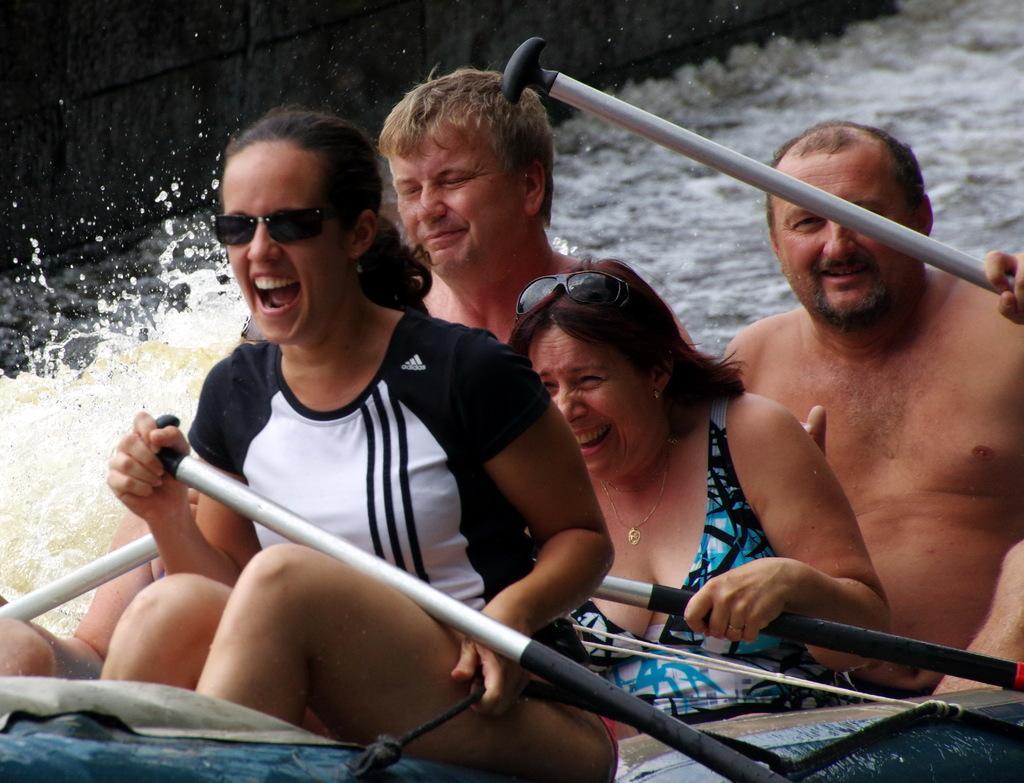Could you give a brief overview of what you see in this image? In the image there are two men and women in swimsuit rafting in a canal. 